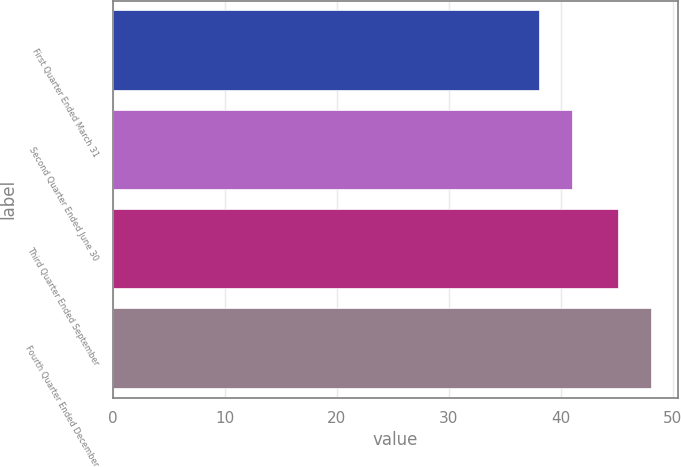Convert chart to OTSL. <chart><loc_0><loc_0><loc_500><loc_500><bar_chart><fcel>First Quarter Ended March 31<fcel>Second Quarter Ended June 30<fcel>Third Quarter Ended September<fcel>Fourth Quarter Ended December<nl><fcel>38.09<fcel>41.02<fcel>45.12<fcel>48.05<nl></chart> 